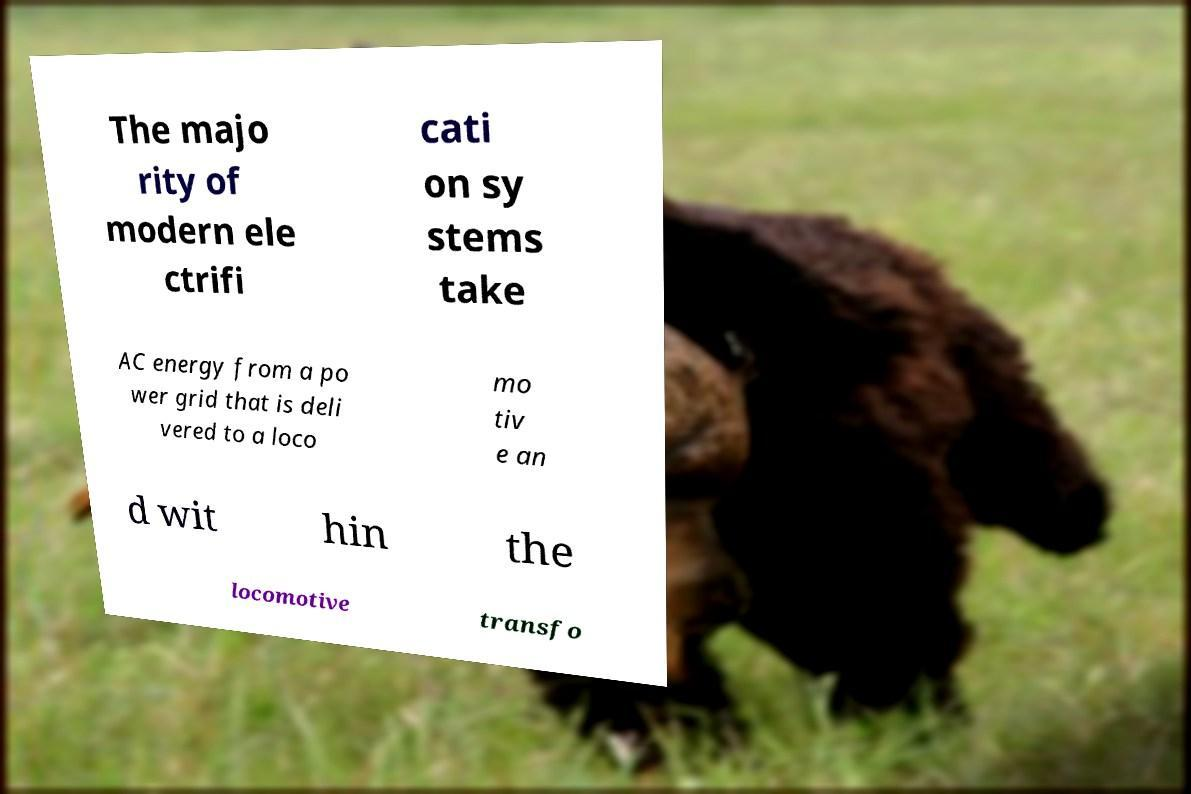There's text embedded in this image that I need extracted. Can you transcribe it verbatim? The majo rity of modern ele ctrifi cati on sy stems take AC energy from a po wer grid that is deli vered to a loco mo tiv e an d wit hin the locomotive transfo 